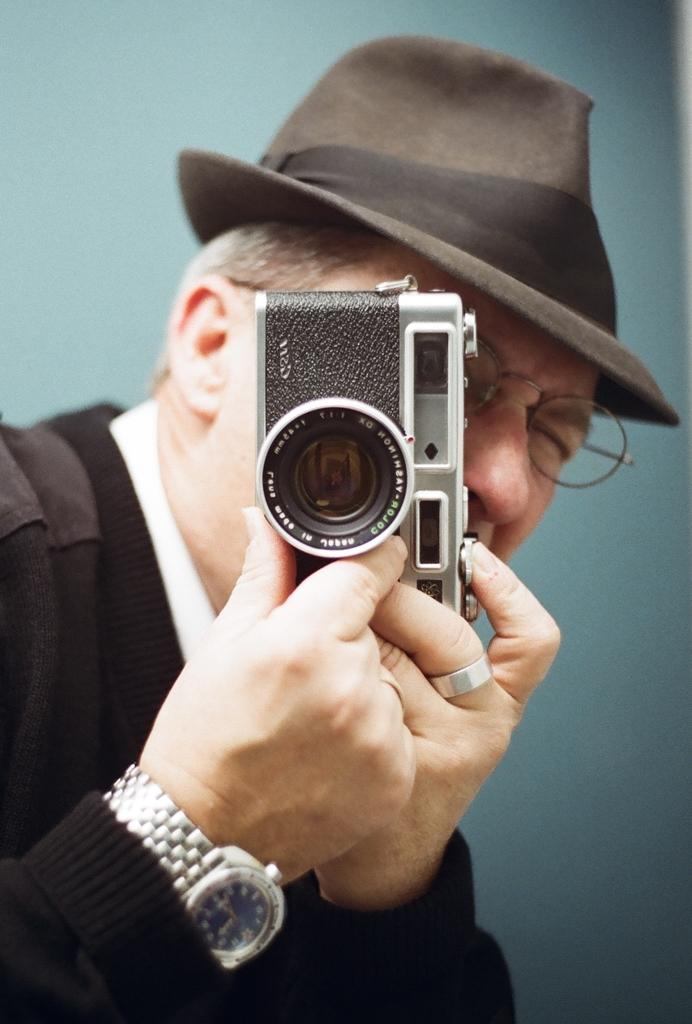What is the main subject of the image? The main subject of the image is a man. What is the man wearing on his head? The man is wearing a black hat. What is the man wearing on his body? The man is wearing a black dress. What is the man holding in his hand? The man is holding a camera in his hand. What accessory is the man wearing on his wrist? The man is wearing a watch. What type of eyewear is the man wearing? The man is wearing specs. What type of haircut does the man have in the image? The provided facts do not mention the man's haircut, so we cannot determine it from the image. What trade is the man involved in, as depicted in the image? The provided facts do not mention the man's trade or occupation, so we cannot determine it from the image. 